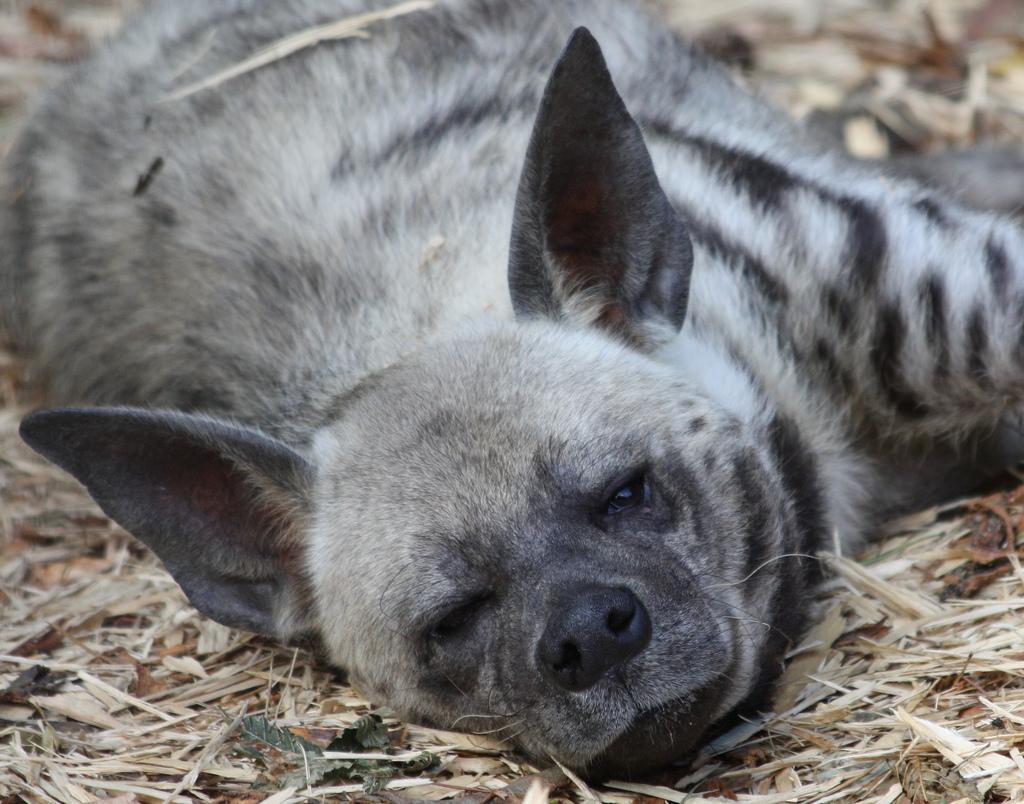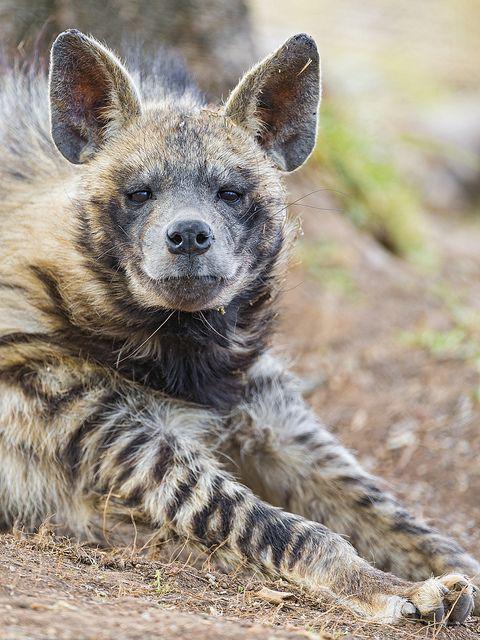The first image is the image on the left, the second image is the image on the right. Evaluate the accuracy of this statement regarding the images: "At least one hyena is laying down.". Is it true? Answer yes or no. Yes. The first image is the image on the left, the second image is the image on the right. For the images displayed, is the sentence "No image contains more than one animal, and one image features an adult hyena in a standing pose with its body turned rightward." factually correct? Answer yes or no. No. 